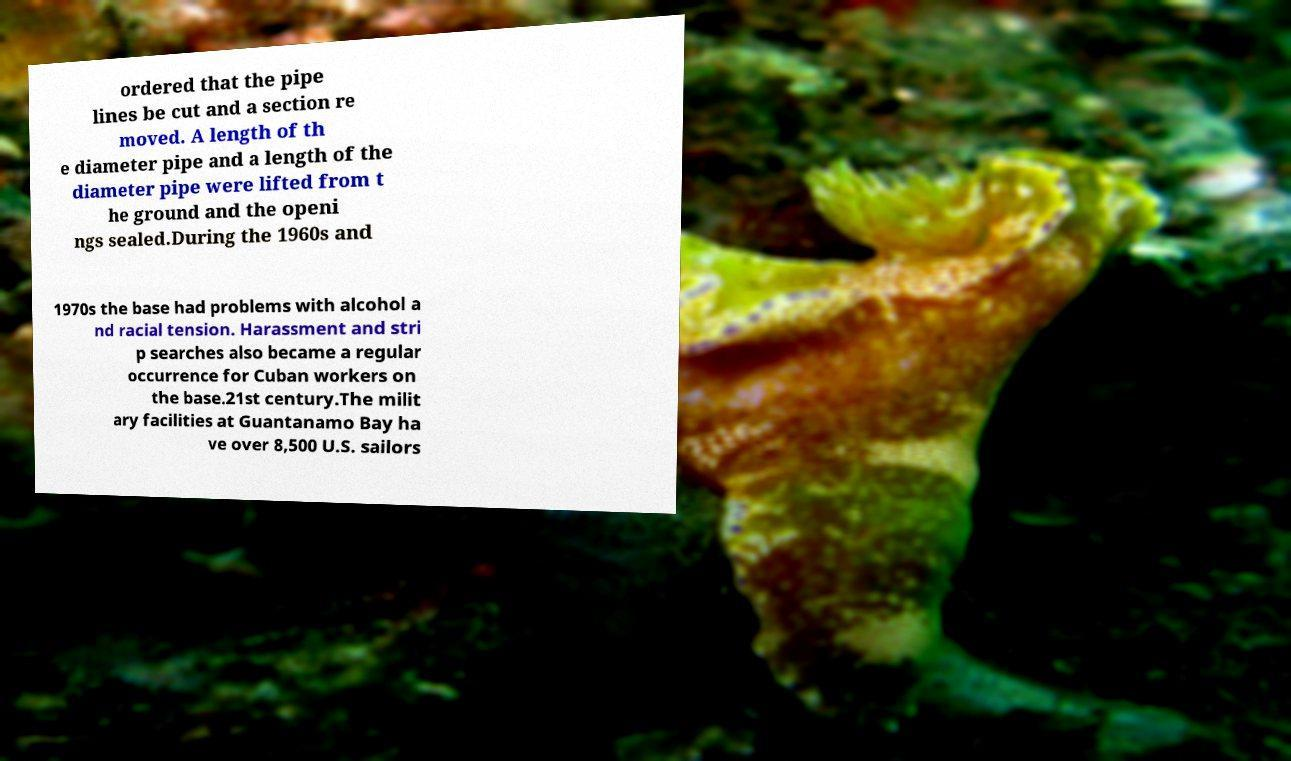There's text embedded in this image that I need extracted. Can you transcribe it verbatim? ordered that the pipe lines be cut and a section re moved. A length of th e diameter pipe and a length of the diameter pipe were lifted from t he ground and the openi ngs sealed.During the 1960s and 1970s the base had problems with alcohol a nd racial tension. Harassment and stri p searches also became a regular occurrence for Cuban workers on the base.21st century.The milit ary facilities at Guantanamo Bay ha ve over 8,500 U.S. sailors 